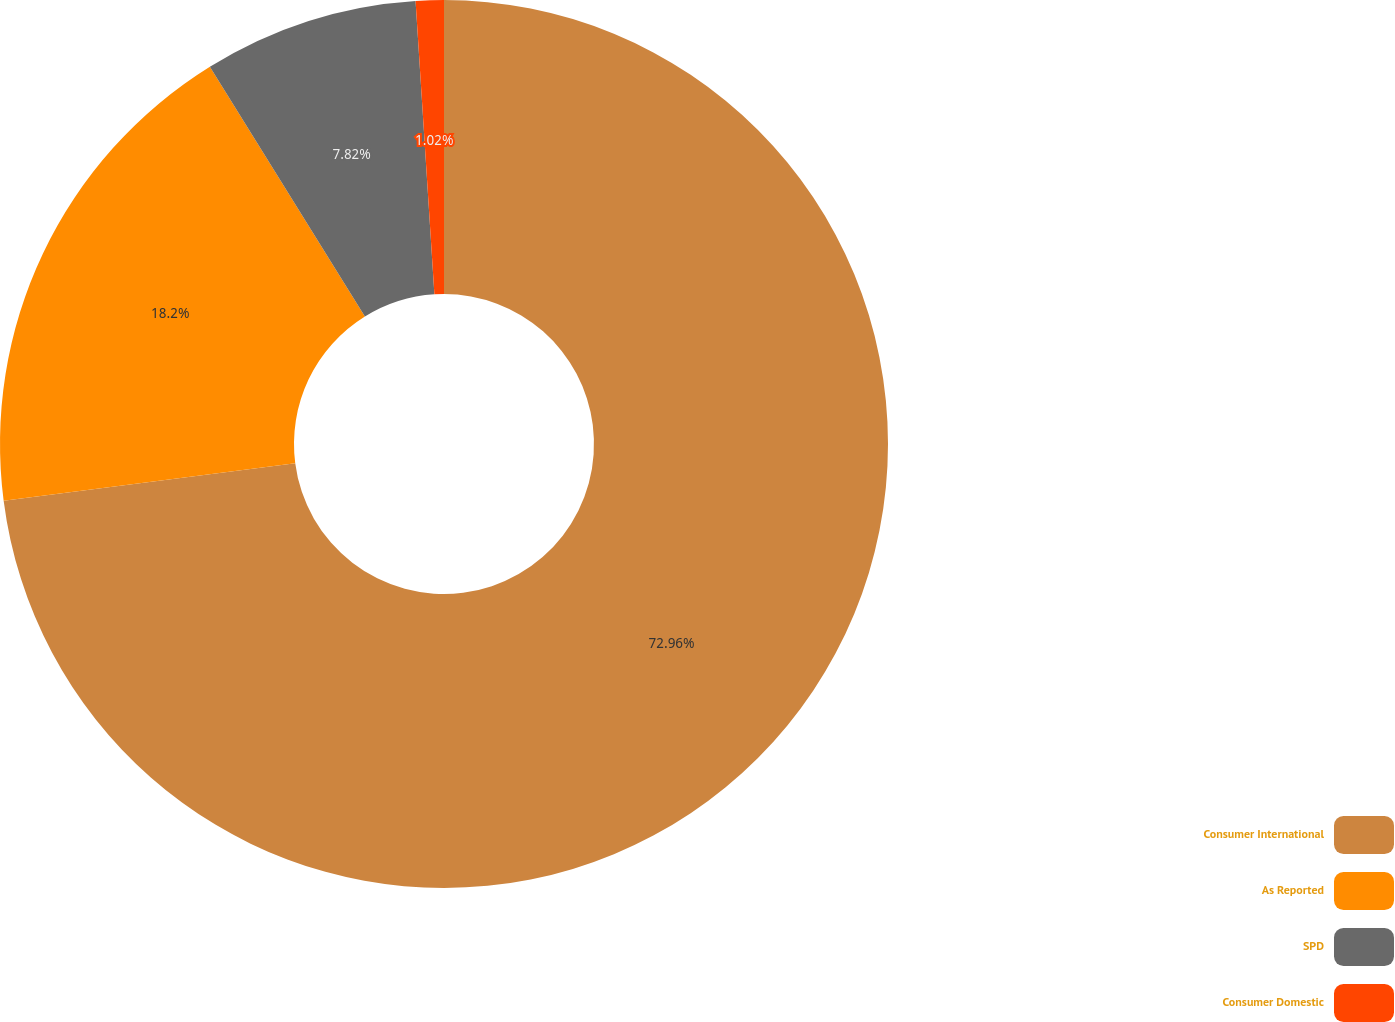Convert chart. <chart><loc_0><loc_0><loc_500><loc_500><pie_chart><fcel>Consumer International<fcel>As Reported<fcel>SPD<fcel>Consumer Domestic<nl><fcel>72.96%<fcel>18.2%<fcel>7.82%<fcel>1.02%<nl></chart> 